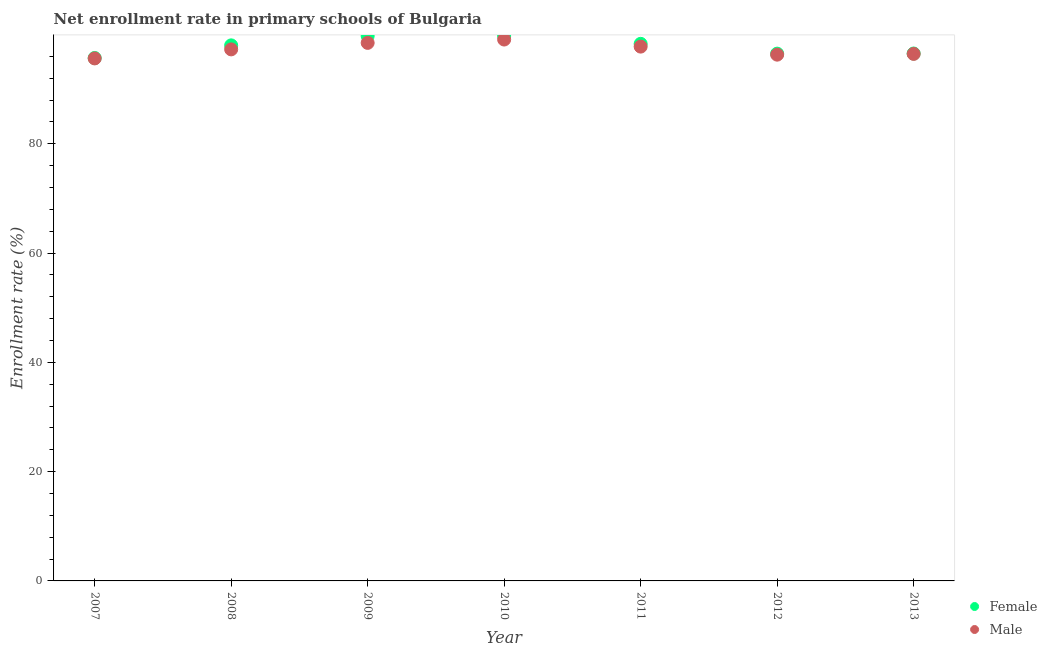What is the enrollment rate of male students in 2009?
Ensure brevity in your answer.  98.48. Across all years, what is the maximum enrollment rate of male students?
Give a very brief answer. 99.09. Across all years, what is the minimum enrollment rate of female students?
Make the answer very short. 95.71. In which year was the enrollment rate of male students minimum?
Provide a short and direct response. 2007. What is the total enrollment rate of male students in the graph?
Make the answer very short. 681.06. What is the difference between the enrollment rate of female students in 2011 and that in 2012?
Make the answer very short. 1.79. What is the difference between the enrollment rate of male students in 2010 and the enrollment rate of female students in 2008?
Offer a very short reply. 1.07. What is the average enrollment rate of male students per year?
Offer a very short reply. 97.29. In the year 2011, what is the difference between the enrollment rate of female students and enrollment rate of male students?
Provide a succinct answer. 0.51. What is the ratio of the enrollment rate of male students in 2009 to that in 2012?
Your response must be concise. 1.02. Is the difference between the enrollment rate of male students in 2007 and 2008 greater than the difference between the enrollment rate of female students in 2007 and 2008?
Provide a short and direct response. Yes. What is the difference between the highest and the second highest enrollment rate of male students?
Your answer should be very brief. 0.61. What is the difference between the highest and the lowest enrollment rate of male students?
Your answer should be compact. 3.46. In how many years, is the enrollment rate of male students greater than the average enrollment rate of male students taken over all years?
Your response must be concise. 3. Is the enrollment rate of male students strictly less than the enrollment rate of female students over the years?
Provide a succinct answer. Yes. Are the values on the major ticks of Y-axis written in scientific E-notation?
Your answer should be very brief. No. Does the graph contain any zero values?
Give a very brief answer. No. How are the legend labels stacked?
Your answer should be compact. Vertical. What is the title of the graph?
Offer a very short reply. Net enrollment rate in primary schools of Bulgaria. What is the label or title of the Y-axis?
Provide a succinct answer. Enrollment rate (%). What is the Enrollment rate (%) in Female in 2007?
Keep it short and to the point. 95.71. What is the Enrollment rate (%) of Male in 2007?
Provide a short and direct response. 95.63. What is the Enrollment rate (%) in Female in 2008?
Keep it short and to the point. 98.02. What is the Enrollment rate (%) in Male in 2008?
Keep it short and to the point. 97.29. What is the Enrollment rate (%) of Female in 2009?
Make the answer very short. 99.73. What is the Enrollment rate (%) of Male in 2009?
Keep it short and to the point. 98.48. What is the Enrollment rate (%) of Female in 2010?
Offer a terse response. 99.74. What is the Enrollment rate (%) in Male in 2010?
Ensure brevity in your answer.  99.09. What is the Enrollment rate (%) in Female in 2011?
Ensure brevity in your answer.  98.3. What is the Enrollment rate (%) in Male in 2011?
Ensure brevity in your answer.  97.79. What is the Enrollment rate (%) of Female in 2012?
Your response must be concise. 96.51. What is the Enrollment rate (%) of Male in 2012?
Your answer should be compact. 96.32. What is the Enrollment rate (%) of Female in 2013?
Offer a very short reply. 96.53. What is the Enrollment rate (%) of Male in 2013?
Provide a short and direct response. 96.46. Across all years, what is the maximum Enrollment rate (%) in Female?
Provide a succinct answer. 99.74. Across all years, what is the maximum Enrollment rate (%) in Male?
Offer a very short reply. 99.09. Across all years, what is the minimum Enrollment rate (%) of Female?
Your answer should be compact. 95.71. Across all years, what is the minimum Enrollment rate (%) of Male?
Keep it short and to the point. 95.63. What is the total Enrollment rate (%) of Female in the graph?
Ensure brevity in your answer.  684.53. What is the total Enrollment rate (%) in Male in the graph?
Offer a very short reply. 681.05. What is the difference between the Enrollment rate (%) of Female in 2007 and that in 2008?
Ensure brevity in your answer.  -2.31. What is the difference between the Enrollment rate (%) in Male in 2007 and that in 2008?
Keep it short and to the point. -1.65. What is the difference between the Enrollment rate (%) in Female in 2007 and that in 2009?
Give a very brief answer. -4.02. What is the difference between the Enrollment rate (%) in Male in 2007 and that in 2009?
Your response must be concise. -2.85. What is the difference between the Enrollment rate (%) of Female in 2007 and that in 2010?
Keep it short and to the point. -4.02. What is the difference between the Enrollment rate (%) in Male in 2007 and that in 2010?
Keep it short and to the point. -3.46. What is the difference between the Enrollment rate (%) of Female in 2007 and that in 2011?
Ensure brevity in your answer.  -2.59. What is the difference between the Enrollment rate (%) of Male in 2007 and that in 2011?
Ensure brevity in your answer.  -2.16. What is the difference between the Enrollment rate (%) of Female in 2007 and that in 2012?
Your response must be concise. -0.79. What is the difference between the Enrollment rate (%) of Male in 2007 and that in 2012?
Ensure brevity in your answer.  -0.69. What is the difference between the Enrollment rate (%) in Female in 2007 and that in 2013?
Your answer should be compact. -0.82. What is the difference between the Enrollment rate (%) in Male in 2007 and that in 2013?
Keep it short and to the point. -0.83. What is the difference between the Enrollment rate (%) of Female in 2008 and that in 2009?
Offer a terse response. -1.71. What is the difference between the Enrollment rate (%) in Male in 2008 and that in 2009?
Provide a succinct answer. -1.19. What is the difference between the Enrollment rate (%) in Female in 2008 and that in 2010?
Make the answer very short. -1.72. What is the difference between the Enrollment rate (%) of Male in 2008 and that in 2010?
Provide a succinct answer. -1.8. What is the difference between the Enrollment rate (%) in Female in 2008 and that in 2011?
Provide a short and direct response. -0.28. What is the difference between the Enrollment rate (%) of Male in 2008 and that in 2011?
Ensure brevity in your answer.  -0.51. What is the difference between the Enrollment rate (%) of Female in 2008 and that in 2012?
Offer a terse response. 1.51. What is the difference between the Enrollment rate (%) of Male in 2008 and that in 2012?
Keep it short and to the point. 0.97. What is the difference between the Enrollment rate (%) in Female in 2008 and that in 2013?
Keep it short and to the point. 1.49. What is the difference between the Enrollment rate (%) in Male in 2008 and that in 2013?
Keep it short and to the point. 0.83. What is the difference between the Enrollment rate (%) of Female in 2009 and that in 2010?
Keep it short and to the point. -0.01. What is the difference between the Enrollment rate (%) in Male in 2009 and that in 2010?
Keep it short and to the point. -0.61. What is the difference between the Enrollment rate (%) in Female in 2009 and that in 2011?
Offer a very short reply. 1.43. What is the difference between the Enrollment rate (%) of Male in 2009 and that in 2011?
Offer a terse response. 0.68. What is the difference between the Enrollment rate (%) of Female in 2009 and that in 2012?
Offer a terse response. 3.22. What is the difference between the Enrollment rate (%) of Male in 2009 and that in 2012?
Ensure brevity in your answer.  2.16. What is the difference between the Enrollment rate (%) of Female in 2009 and that in 2013?
Provide a succinct answer. 3.2. What is the difference between the Enrollment rate (%) in Male in 2009 and that in 2013?
Offer a very short reply. 2.02. What is the difference between the Enrollment rate (%) of Female in 2010 and that in 2011?
Your answer should be very brief. 1.44. What is the difference between the Enrollment rate (%) in Male in 2010 and that in 2011?
Provide a succinct answer. 1.29. What is the difference between the Enrollment rate (%) in Female in 2010 and that in 2012?
Your response must be concise. 3.23. What is the difference between the Enrollment rate (%) of Male in 2010 and that in 2012?
Your response must be concise. 2.77. What is the difference between the Enrollment rate (%) in Female in 2010 and that in 2013?
Give a very brief answer. 3.21. What is the difference between the Enrollment rate (%) in Male in 2010 and that in 2013?
Your answer should be compact. 2.63. What is the difference between the Enrollment rate (%) of Female in 2011 and that in 2012?
Make the answer very short. 1.79. What is the difference between the Enrollment rate (%) in Male in 2011 and that in 2012?
Give a very brief answer. 1.47. What is the difference between the Enrollment rate (%) in Female in 2011 and that in 2013?
Ensure brevity in your answer.  1.77. What is the difference between the Enrollment rate (%) in Male in 2011 and that in 2013?
Your response must be concise. 1.33. What is the difference between the Enrollment rate (%) in Female in 2012 and that in 2013?
Offer a very short reply. -0.02. What is the difference between the Enrollment rate (%) in Male in 2012 and that in 2013?
Offer a very short reply. -0.14. What is the difference between the Enrollment rate (%) of Female in 2007 and the Enrollment rate (%) of Male in 2008?
Offer a very short reply. -1.57. What is the difference between the Enrollment rate (%) in Female in 2007 and the Enrollment rate (%) in Male in 2009?
Keep it short and to the point. -2.76. What is the difference between the Enrollment rate (%) of Female in 2007 and the Enrollment rate (%) of Male in 2010?
Make the answer very short. -3.38. What is the difference between the Enrollment rate (%) of Female in 2007 and the Enrollment rate (%) of Male in 2011?
Keep it short and to the point. -2.08. What is the difference between the Enrollment rate (%) of Female in 2007 and the Enrollment rate (%) of Male in 2012?
Your answer should be very brief. -0.61. What is the difference between the Enrollment rate (%) of Female in 2007 and the Enrollment rate (%) of Male in 2013?
Keep it short and to the point. -0.75. What is the difference between the Enrollment rate (%) in Female in 2008 and the Enrollment rate (%) in Male in 2009?
Your response must be concise. -0.46. What is the difference between the Enrollment rate (%) of Female in 2008 and the Enrollment rate (%) of Male in 2010?
Make the answer very short. -1.07. What is the difference between the Enrollment rate (%) in Female in 2008 and the Enrollment rate (%) in Male in 2011?
Your response must be concise. 0.23. What is the difference between the Enrollment rate (%) in Female in 2008 and the Enrollment rate (%) in Male in 2012?
Offer a very short reply. 1.7. What is the difference between the Enrollment rate (%) of Female in 2008 and the Enrollment rate (%) of Male in 2013?
Keep it short and to the point. 1.56. What is the difference between the Enrollment rate (%) of Female in 2009 and the Enrollment rate (%) of Male in 2010?
Provide a succinct answer. 0.64. What is the difference between the Enrollment rate (%) in Female in 2009 and the Enrollment rate (%) in Male in 2011?
Provide a succinct answer. 1.94. What is the difference between the Enrollment rate (%) of Female in 2009 and the Enrollment rate (%) of Male in 2012?
Give a very brief answer. 3.41. What is the difference between the Enrollment rate (%) of Female in 2009 and the Enrollment rate (%) of Male in 2013?
Your answer should be compact. 3.27. What is the difference between the Enrollment rate (%) of Female in 2010 and the Enrollment rate (%) of Male in 2011?
Your answer should be very brief. 1.94. What is the difference between the Enrollment rate (%) of Female in 2010 and the Enrollment rate (%) of Male in 2012?
Your answer should be compact. 3.42. What is the difference between the Enrollment rate (%) in Female in 2010 and the Enrollment rate (%) in Male in 2013?
Provide a short and direct response. 3.28. What is the difference between the Enrollment rate (%) of Female in 2011 and the Enrollment rate (%) of Male in 2012?
Your response must be concise. 1.98. What is the difference between the Enrollment rate (%) in Female in 2011 and the Enrollment rate (%) in Male in 2013?
Your answer should be very brief. 1.84. What is the difference between the Enrollment rate (%) in Female in 2012 and the Enrollment rate (%) in Male in 2013?
Make the answer very short. 0.05. What is the average Enrollment rate (%) of Female per year?
Offer a terse response. 97.79. What is the average Enrollment rate (%) in Male per year?
Your response must be concise. 97.29. In the year 2007, what is the difference between the Enrollment rate (%) in Female and Enrollment rate (%) in Male?
Provide a short and direct response. 0.08. In the year 2008, what is the difference between the Enrollment rate (%) in Female and Enrollment rate (%) in Male?
Keep it short and to the point. 0.73. In the year 2009, what is the difference between the Enrollment rate (%) in Female and Enrollment rate (%) in Male?
Your answer should be very brief. 1.25. In the year 2010, what is the difference between the Enrollment rate (%) of Female and Enrollment rate (%) of Male?
Provide a short and direct response. 0.65. In the year 2011, what is the difference between the Enrollment rate (%) of Female and Enrollment rate (%) of Male?
Provide a short and direct response. 0.51. In the year 2012, what is the difference between the Enrollment rate (%) of Female and Enrollment rate (%) of Male?
Ensure brevity in your answer.  0.19. In the year 2013, what is the difference between the Enrollment rate (%) of Female and Enrollment rate (%) of Male?
Ensure brevity in your answer.  0.07. What is the ratio of the Enrollment rate (%) of Female in 2007 to that in 2008?
Offer a terse response. 0.98. What is the ratio of the Enrollment rate (%) of Female in 2007 to that in 2009?
Your response must be concise. 0.96. What is the ratio of the Enrollment rate (%) of Male in 2007 to that in 2009?
Your answer should be compact. 0.97. What is the ratio of the Enrollment rate (%) of Female in 2007 to that in 2010?
Offer a terse response. 0.96. What is the ratio of the Enrollment rate (%) of Male in 2007 to that in 2010?
Your response must be concise. 0.97. What is the ratio of the Enrollment rate (%) of Female in 2007 to that in 2011?
Your response must be concise. 0.97. What is the ratio of the Enrollment rate (%) in Male in 2007 to that in 2011?
Your answer should be very brief. 0.98. What is the ratio of the Enrollment rate (%) in Female in 2007 to that in 2012?
Keep it short and to the point. 0.99. What is the ratio of the Enrollment rate (%) of Male in 2007 to that in 2012?
Provide a short and direct response. 0.99. What is the ratio of the Enrollment rate (%) in Male in 2007 to that in 2013?
Your response must be concise. 0.99. What is the ratio of the Enrollment rate (%) in Female in 2008 to that in 2009?
Provide a short and direct response. 0.98. What is the ratio of the Enrollment rate (%) in Male in 2008 to that in 2009?
Give a very brief answer. 0.99. What is the ratio of the Enrollment rate (%) of Female in 2008 to that in 2010?
Your answer should be compact. 0.98. What is the ratio of the Enrollment rate (%) in Male in 2008 to that in 2010?
Provide a succinct answer. 0.98. What is the ratio of the Enrollment rate (%) in Female in 2008 to that in 2011?
Provide a short and direct response. 1. What is the ratio of the Enrollment rate (%) in Female in 2008 to that in 2012?
Provide a short and direct response. 1.02. What is the ratio of the Enrollment rate (%) of Female in 2008 to that in 2013?
Offer a very short reply. 1.02. What is the ratio of the Enrollment rate (%) of Male in 2008 to that in 2013?
Your answer should be very brief. 1.01. What is the ratio of the Enrollment rate (%) in Female in 2009 to that in 2011?
Offer a terse response. 1.01. What is the ratio of the Enrollment rate (%) of Female in 2009 to that in 2012?
Offer a very short reply. 1.03. What is the ratio of the Enrollment rate (%) in Male in 2009 to that in 2012?
Your answer should be very brief. 1.02. What is the ratio of the Enrollment rate (%) of Female in 2009 to that in 2013?
Keep it short and to the point. 1.03. What is the ratio of the Enrollment rate (%) in Male in 2009 to that in 2013?
Give a very brief answer. 1.02. What is the ratio of the Enrollment rate (%) in Female in 2010 to that in 2011?
Make the answer very short. 1.01. What is the ratio of the Enrollment rate (%) of Male in 2010 to that in 2011?
Provide a short and direct response. 1.01. What is the ratio of the Enrollment rate (%) of Female in 2010 to that in 2012?
Offer a very short reply. 1.03. What is the ratio of the Enrollment rate (%) of Male in 2010 to that in 2012?
Make the answer very short. 1.03. What is the ratio of the Enrollment rate (%) in Female in 2010 to that in 2013?
Offer a terse response. 1.03. What is the ratio of the Enrollment rate (%) in Male in 2010 to that in 2013?
Your answer should be compact. 1.03. What is the ratio of the Enrollment rate (%) in Female in 2011 to that in 2012?
Your answer should be compact. 1.02. What is the ratio of the Enrollment rate (%) in Male in 2011 to that in 2012?
Ensure brevity in your answer.  1.02. What is the ratio of the Enrollment rate (%) in Female in 2011 to that in 2013?
Provide a succinct answer. 1.02. What is the ratio of the Enrollment rate (%) of Male in 2011 to that in 2013?
Give a very brief answer. 1.01. What is the ratio of the Enrollment rate (%) in Female in 2012 to that in 2013?
Offer a very short reply. 1. What is the difference between the highest and the second highest Enrollment rate (%) in Female?
Your answer should be compact. 0.01. What is the difference between the highest and the second highest Enrollment rate (%) in Male?
Ensure brevity in your answer.  0.61. What is the difference between the highest and the lowest Enrollment rate (%) in Female?
Offer a very short reply. 4.02. What is the difference between the highest and the lowest Enrollment rate (%) in Male?
Offer a very short reply. 3.46. 